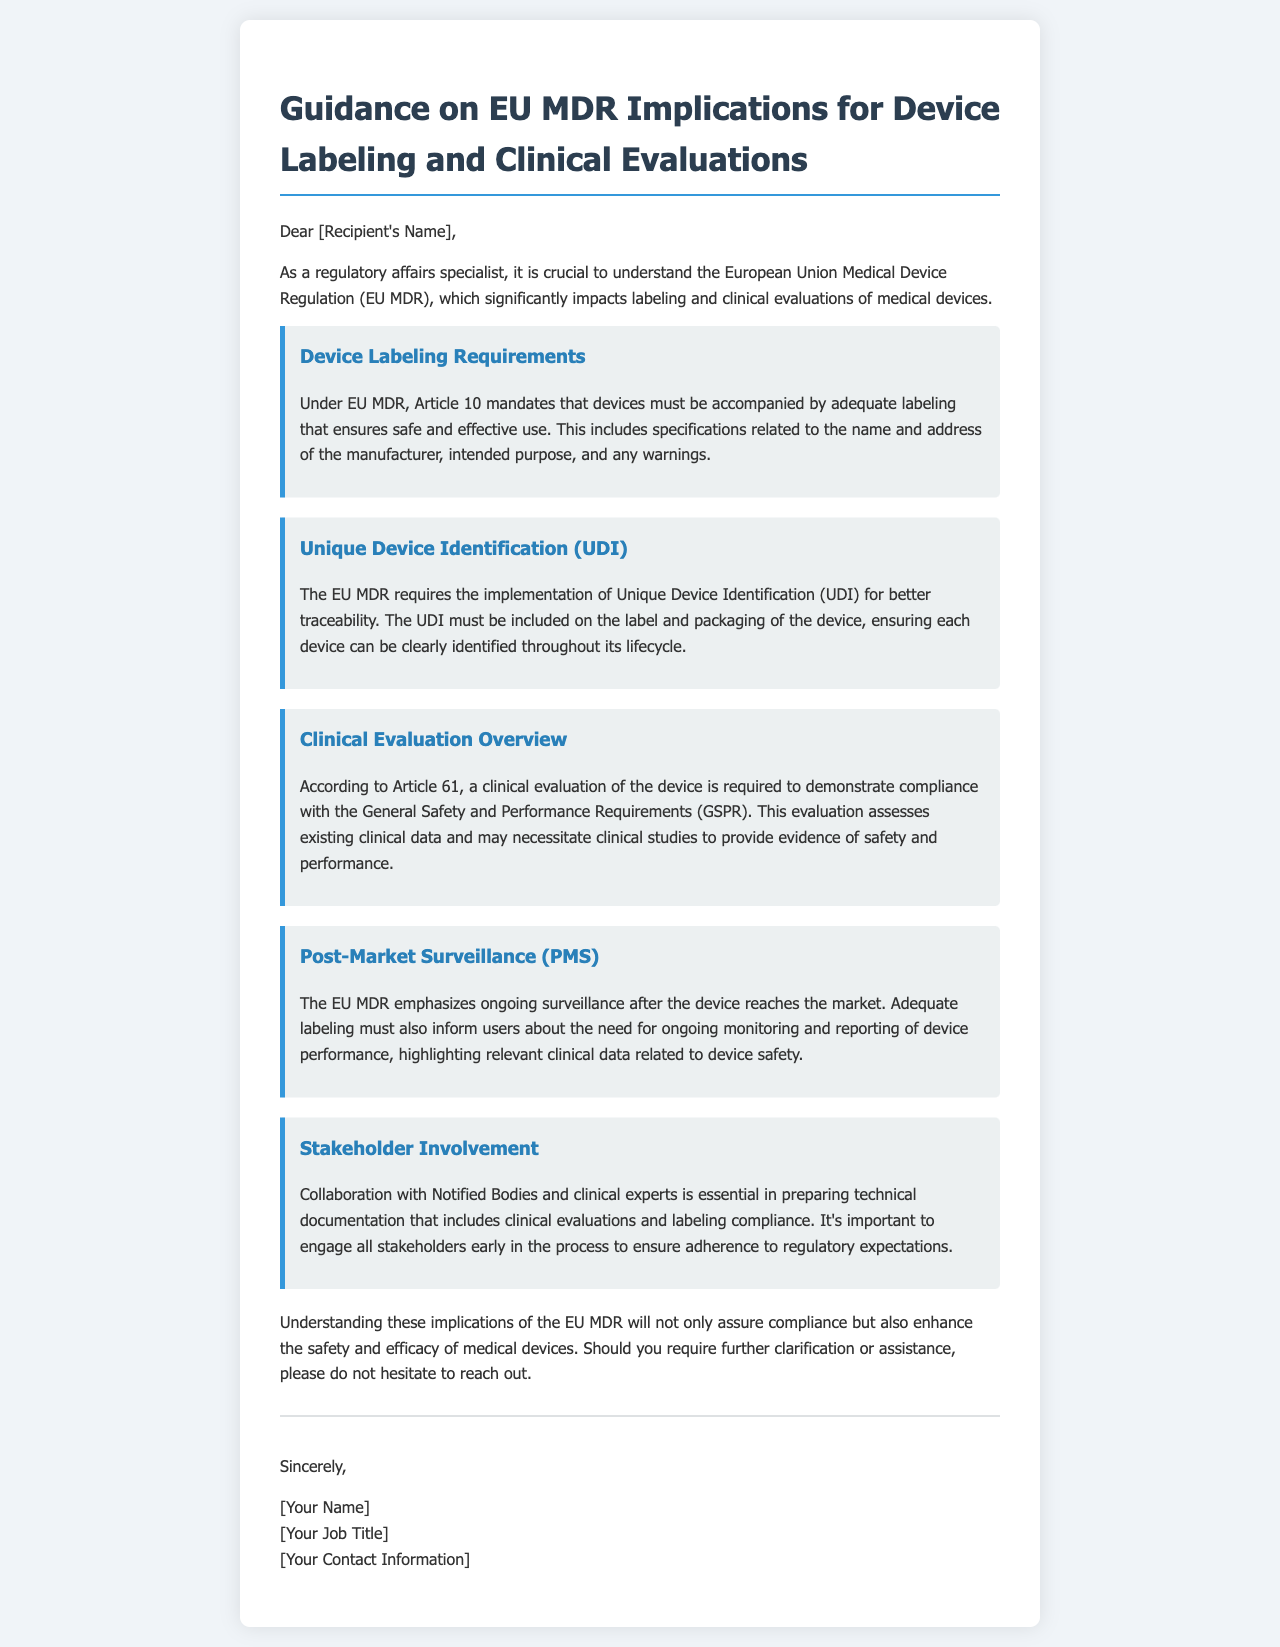What is the title of the letter? The title is stated prominently at the beginning of the letter as the guidance subject.
Answer: Guidance on EU MDR Implications for Device Labeling and Clinical Evaluations What article of EU MDR covers device labeling requirements? The article number is mentioned in correlation with the labeling requirements discussed in the document.
Answer: Article 10 What is required on the label for traceability? The requirement for traceability is specifically termed in the document regarding labeling criteria.
Answer: Unique Device Identification (UDI) What does a clinical evaluation assess according to the letter? The letter specifies what a clinical evaluation must demonstrate in relation to the medical device and its compliance.
Answer: Existing clinical data Which segment of the document mentions ongoing surveillance? The relevant aspect discussing post-market actions is categorized under a specific heading.
Answer: Post-Market Surveillance (PMS) Who should collaborate in preparing technical documentation? The collaboration requirement is highlighted in a specific section that outlines stakeholder involvement.
Answer: Notified Bodies and clinical experts What should the labeling inform users about? The specific guidance around the information that must be available to users is addressed in the context of monitoring needs.
Answer: Ongoing monitoring and reporting of device performance What is the purpose of engaging stakeholders early in the process? The intent behind early involvement of different parties is explained in relation to regulatory expectations.
Answer: Ensure adherence to regulatory expectations 